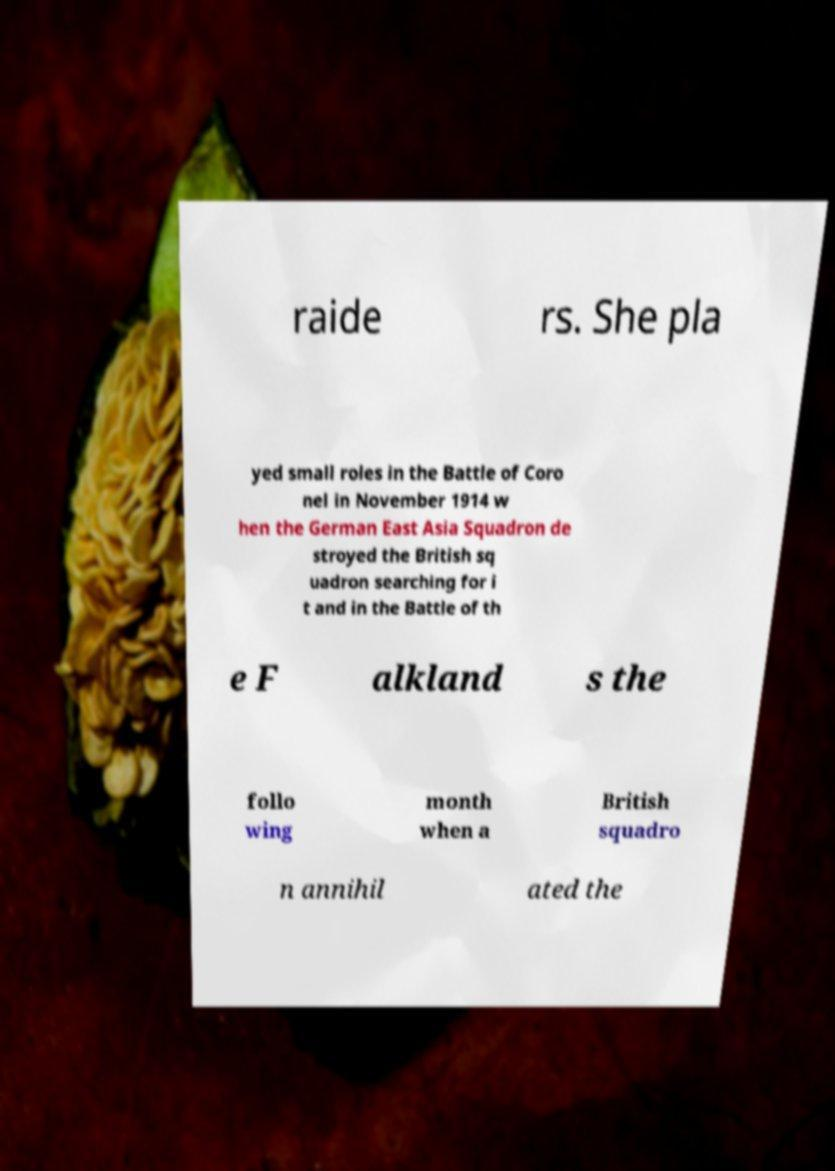Please identify and transcribe the text found in this image. raide rs. She pla yed small roles in the Battle of Coro nel in November 1914 w hen the German East Asia Squadron de stroyed the British sq uadron searching for i t and in the Battle of th e F alkland s the follo wing month when a British squadro n annihil ated the 